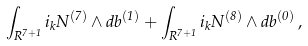<formula> <loc_0><loc_0><loc_500><loc_500>\int _ { R ^ { 7 + 1 } } i _ { k } N ^ { ( 7 ) } \wedge d b ^ { ( 1 ) } + \int _ { R ^ { 7 + 1 } } i _ { k } N ^ { ( 8 ) } \wedge d b ^ { ( 0 ) } \, ,</formula> 